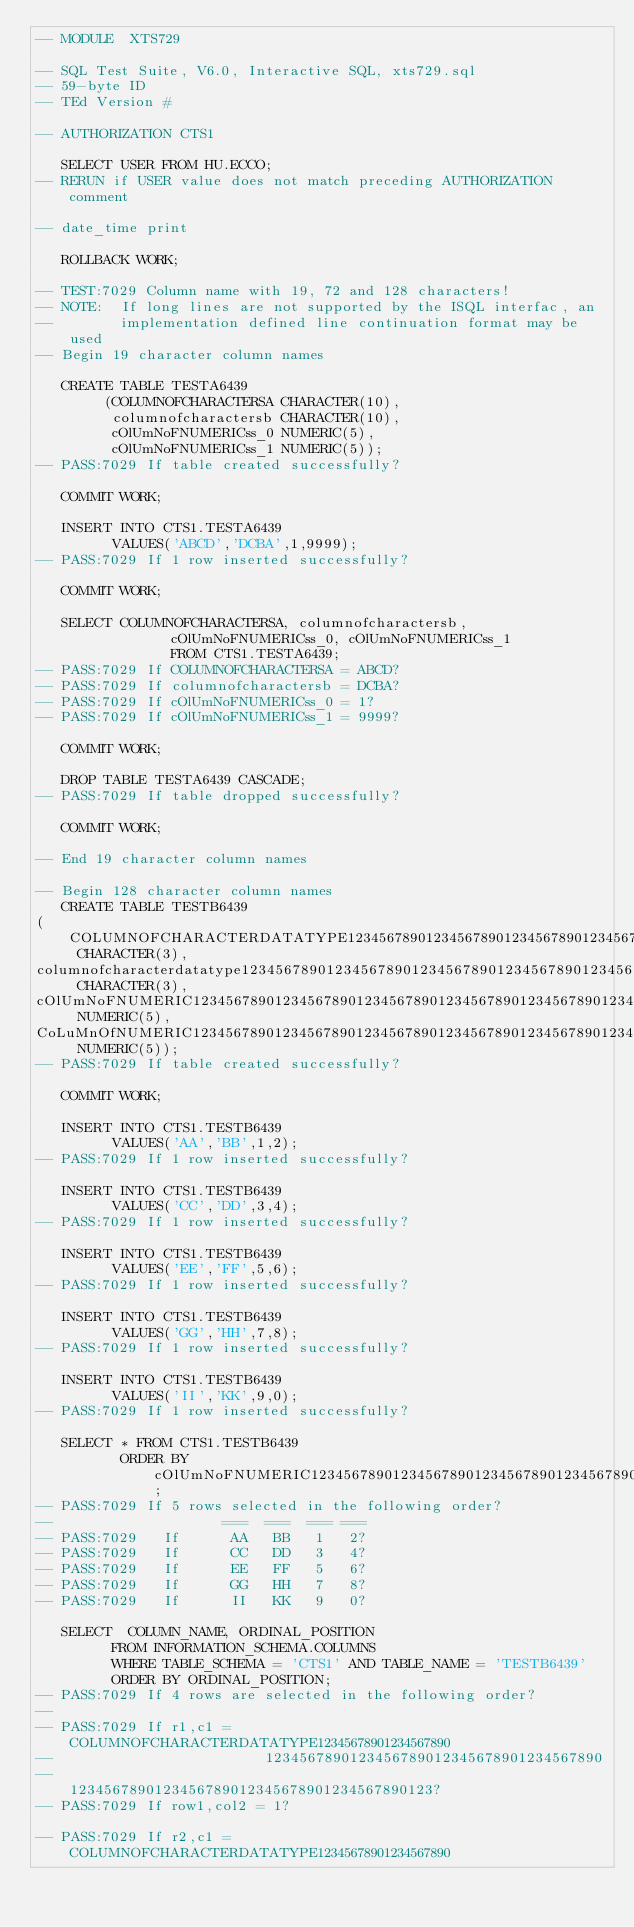Convert code to text. <code><loc_0><loc_0><loc_500><loc_500><_SQL_>-- MODULE  XTS729

-- SQL Test Suite, V6.0, Interactive SQL, xts729.sql
-- 59-byte ID
-- TEd Version #

-- AUTHORIZATION CTS1              

   SELECT USER FROM HU.ECCO;
-- RERUN if USER value does not match preceding AUTHORIZATION comment

-- date_time print

   ROLLBACK WORK;

-- TEST:7029 Column name with 19, 72 and 128 characters!
-- NOTE:  If long lines are not supported by the ISQL interfac, an
--        implementation defined line continuation format may be used
-- Begin 19 character column names

   CREATE TABLE TESTA6439
        (COLUMNOFCHARACTERSA CHARACTER(10),
         columnofcharactersb CHARACTER(10),
         cOlUmNoFNUMERICss_0 NUMERIC(5),
         cOlUmNoFNUMERICss_1 NUMERIC(5));
-- PASS:7029 If table created successfully?

   COMMIT WORK;

   INSERT INTO CTS1.TESTA6439
         VALUES('ABCD','DCBA',1,9999);
-- PASS:7029 If 1 row inserted successfully?

   COMMIT WORK;

   SELECT COLUMNOFCHARACTERSA, columnofcharactersb,
                cOlUmNoFNUMERICss_0, cOlUmNoFNUMERICss_1
                FROM CTS1.TESTA6439;
-- PASS:7029 If COLUMNOFCHARACTERSA = ABCD?
-- PASS:7029 If columnofcharactersb = DCBA?
-- PASS:7029 If cOlUmNoFNUMERICss_0 = 1?
-- PASS:7029 If cOlUmNoFNUMERICss_1 = 9999?
   
   COMMIT WORK;

   DROP TABLE TESTA6439 CASCADE;
-- PASS:7029 If table dropped successfully?

   COMMIT WORK;

-- End 19 character column names

-- Begin 128 character column names
   CREATE TABLE TESTB6439
(COLUMNOFCHARACTERDATATYPE1234567890123456789012345678901234567890123456789012345678901234567890123456789012345678901234567890123 CHARACTER(3),
columnofcharacterdatatype123456789012345678901234567890123456789012345678901234567890123456789012345678901234567890123456789012b CHARACTER(3),
cOlUmNoFNUMERIC123456789012345678901234567890123456789012345678901234567890123456789012345678901234567890123456789012345678901_0 NUMERIC(5),
CoLuMnOfNUMERIC123456789012345678901234567890123456789012345678901234567890123456789012345678901234567890123456789012345678901_1 NUMERIC(5));
-- PASS:7029 If table created successfully?

   COMMIT WORK;

   INSERT INTO CTS1.TESTB6439
         VALUES('AA','BB',1,2);
-- PASS:7029 If 1 row inserted successfully?

   INSERT INTO CTS1.TESTB6439
         VALUES('CC','DD',3,4);
-- PASS:7029 If 1 row inserted successfully?

   INSERT INTO CTS1.TESTB6439
         VALUES('EE','FF',5,6);
-- PASS:7029 If 1 row inserted successfully?

   INSERT INTO CTS1.TESTB6439
         VALUES('GG','HH',7,8);
-- PASS:7029 If 1 row inserted successfully?

   INSERT INTO CTS1.TESTB6439
         VALUES('II','KK',9,0);
-- PASS:7029 If 1 row inserted successfully?

   SELECT * FROM CTS1.TESTB6439
          ORDER BY cOlUmNoFNUMERIC123456789012345678901234567890123456789012345678901234567890123456789012345678901234567890123456789012345678901_0;
-- PASS:7029 If 5 rows selected in the following order?
--                    ===  ===  === ===
-- PASS:7029   If      AA   BB   1   2?
-- PASS:7029   If      CC   DD   3   4?
-- PASS:7029   If      EE   FF   5   6?
-- PASS:7029   If      GG   HH   7   8?
-- PASS:7029   If      II   KK   9   0?

   SELECT  COLUMN_NAME, ORDINAL_POSITION
         FROM INFORMATION_SCHEMA.COLUMNS
         WHERE TABLE_SCHEMA = 'CTS1' AND TABLE_NAME = 'TESTB6439'
         ORDER BY ORDINAL_POSITION;
-- PASS:7029 If 4 rows are selected in the following order?
--
-- PASS:7029 If r1,c1 = COLUMNOFCHARACTERDATATYPE12345678901234567890
--                         1234567890123456789012345678901234567890
--                         1234567890123456789012345678901234567890123?
-- PASS:7029 If row1,col2 = 1?

-- PASS:7029 If r2,c1 = COLUMNOFCHARACTERDATATYPE12345678901234567890</code> 